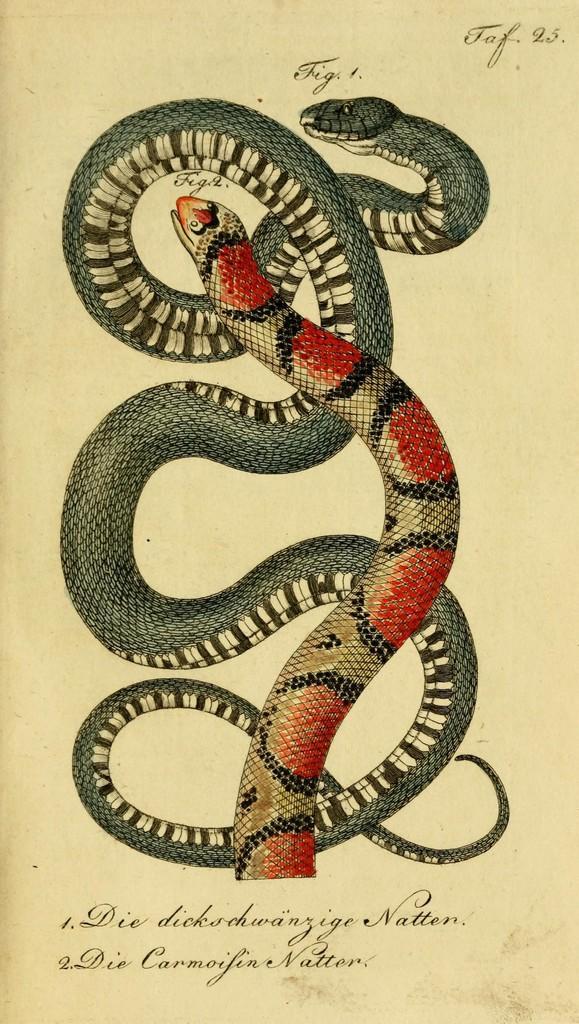How would you summarize this image in a sentence or two? In this image we can see a paper and on the paper we can see the depiction of snakes. We can also see the text. 